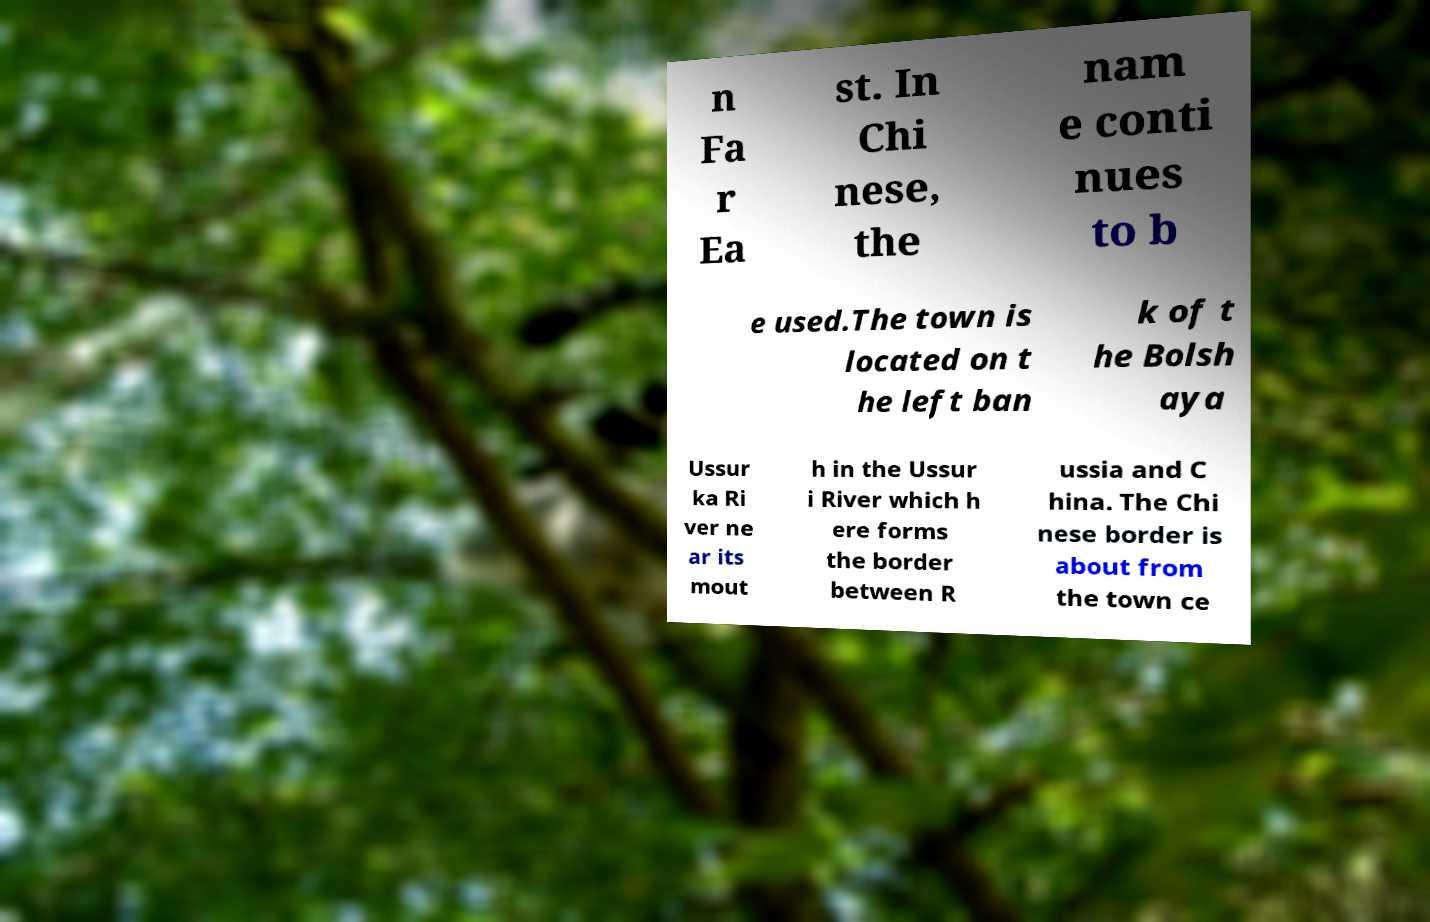Can you accurately transcribe the text from the provided image for me? n Fa r Ea st. In Chi nese, the nam e conti nues to b e used.The town is located on t he left ban k of t he Bolsh aya Ussur ka Ri ver ne ar its mout h in the Ussur i River which h ere forms the border between R ussia and C hina. The Chi nese border is about from the town ce 